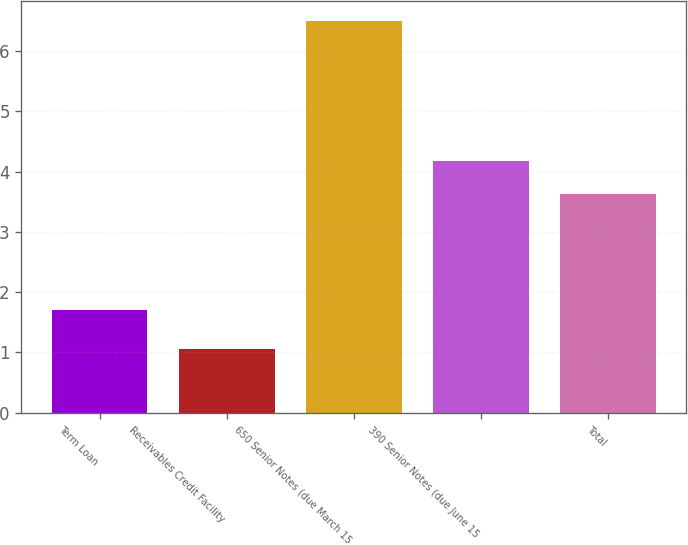<chart> <loc_0><loc_0><loc_500><loc_500><bar_chart><fcel>Term Loan<fcel>Receivables Credit Facility<fcel>650 Senior Notes (due March 15<fcel>390 Senior Notes (due June 15<fcel>Total<nl><fcel>1.71<fcel>1.06<fcel>6.5<fcel>4.17<fcel>3.63<nl></chart> 